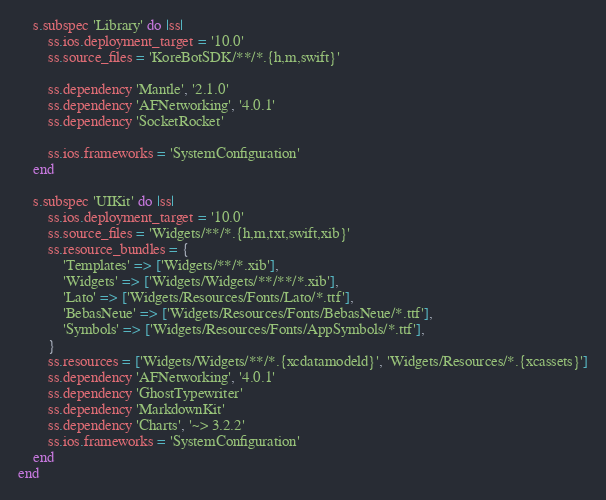Convert code to text. <code><loc_0><loc_0><loc_500><loc_500><_Ruby_>
    s.subspec 'Library' do |ss|
        ss.ios.deployment_target = '10.0'
        ss.source_files = 'KoreBotSDK/**/*.{h,m,swift}'
        
        ss.dependency 'Mantle', '2.1.0'
        ss.dependency 'AFNetworking', '4.0.1'
        ss.dependency 'SocketRocket'
        
        ss.ios.frameworks = 'SystemConfiguration'
    end

    s.subspec 'UIKit' do |ss|
        ss.ios.deployment_target = '10.0'
        ss.source_files = 'Widgets/**/*.{h,m,txt,swift,xib}'
        ss.resource_bundles = {
            'Templates' => ['Widgets/**/*.xib'],
            'Widgets' => ['Widgets/Widgets/**/**/*.xib'],
            'Lato' => ['Widgets/Resources/Fonts/Lato/*.ttf'],
            'BebasNeue' => ['Widgets/Resources/Fonts/BebasNeue/*.ttf'],
            'Symbols' => ['Widgets/Resources/Fonts/AppSymbols/*.ttf'],
        }
        ss.resources = ['Widgets/Widgets/**/*.{xcdatamodeld}', 'Widgets/Resources/*.{xcassets}']
        ss.dependency 'AFNetworking', '4.0.1'
        ss.dependency 'GhostTypewriter'
        ss.dependency 'MarkdownKit'
        ss.dependency 'Charts', '~> 3.2.2'
        ss.ios.frameworks = 'SystemConfiguration'
    end
end
</code> 